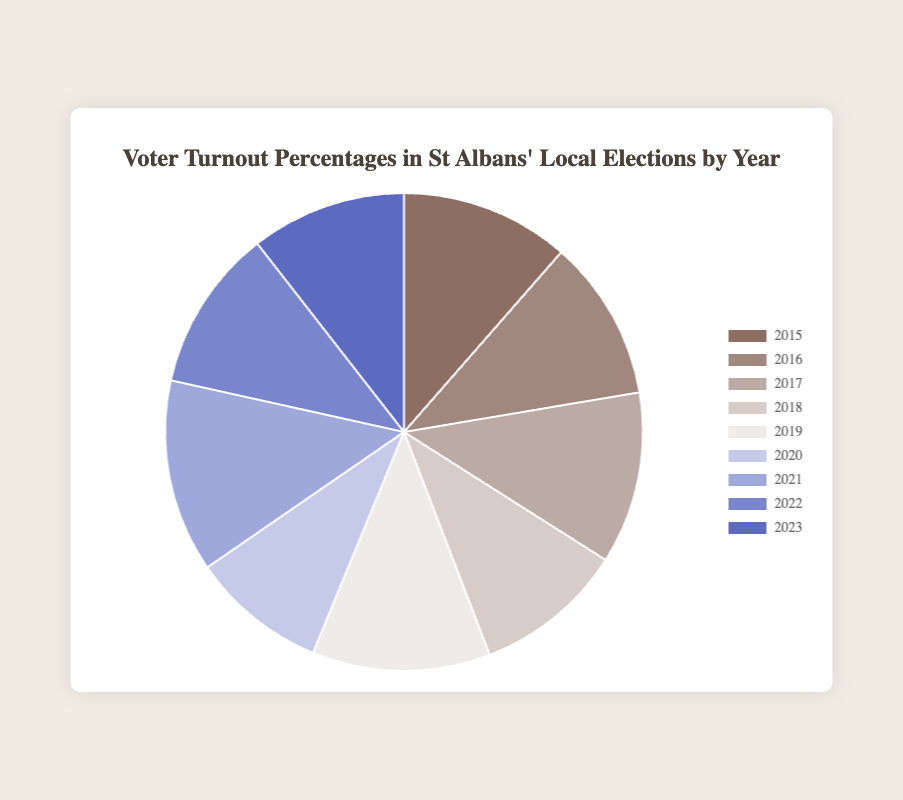What year had the highest voter turnout percentage? The year with the highest voter turnout percentage can be identified by looking for the largest slice in the pie chart's legend. This is labeled as 2021 with a turnout of 41.7%.
Answer: 2021 Which year had a lower voter turnout percentage: 2016 or 2023? Compare the slices for 2016 and 2023. 2016 is labeled with 34.8% and 2023 with 33.6%.
Answer: 2023 What is the difference in voter turnout percentage between 2019 and 2020? From the legend, 2019 shows a turnout of 38.5% and 2020 shows 29.3%. Subtract 29.3 from 38.5 to find the difference.
Answer: 9.2% Which two consecutive years had the smallest change in voter turnout percentage? Compare the differences between consecutive years: 2015-2016 (1.7), 2016-2017 (2.4), 2017-2018 (4.8), 2018-2019 (6.1), 2019-2020 (9.2), 2020-2021 (12.4), 2021-2022 (6.6), 2022-2023 (1.5). The smallest change is between 2022 and 2023.
Answer: 2022 and 2023 What's the average voter turnout percentage over these nine years? Sum the percentages and divide by the number of years. (36.5 + 34.8 + 37.2 + 32.4 + 38.5 + 29.3 + 41.7 + 35.1 + 33.6) / 9.
Answer: 35.44% What year had a voter turnout percentage of 29.3%? Look for the year with this percentage in the legend. It's 2020.
Answer: 2020 Which year is associated with the darkest color in the pie chart? The darkest color corresponds to the earliest year provided, 2015, based on typical gradient schemes.
Answer: 2015 How many years had a turnout percentage greater than 36%? Check the legend for turnouts greater than 36%: 2015 (36.5), 2017 (37.2), 2019 (38.5), 2021 (41.7). There are 4 such years.
Answer: 4 What's the total voter turnout percentage for the years 2018 and 2023 combined? Add the percentages for 2018 and 2023. 32.4 + 33.6 = 66%.
Answer: 66% Which year had a turnout percentage closest to the overall average turnout percentage? First, calculate the overall average (35.44%). The closest value to this average is for the year 2022 with 35.1%.
Answer: 2022 